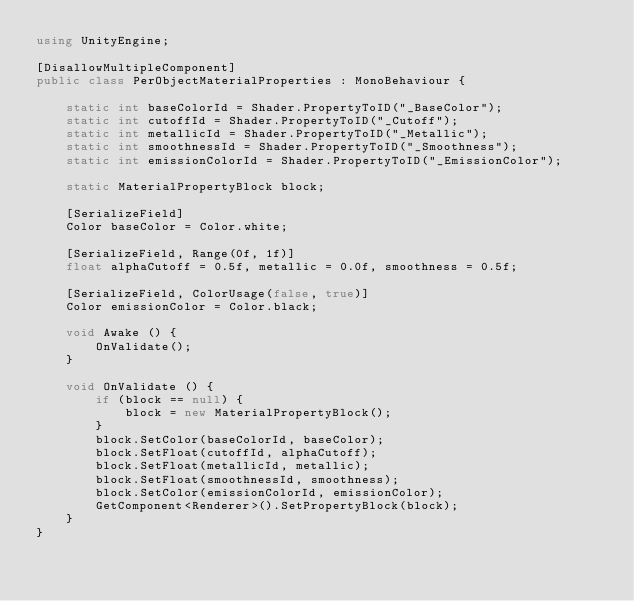<code> <loc_0><loc_0><loc_500><loc_500><_C#_>using UnityEngine;

[DisallowMultipleComponent]
public class PerObjectMaterialProperties : MonoBehaviour {

	static int baseColorId = Shader.PropertyToID("_BaseColor");
	static int cutoffId = Shader.PropertyToID("_Cutoff");
    static int metallicId = Shader.PropertyToID("_Metallic");
    static int smoothnessId = Shader.PropertyToID("_Smoothness");    
    static int emissionColorId = Shader.PropertyToID("_EmissionColor");

	static MaterialPropertyBlock block;

	[SerializeField]
	Color baseColor = Color.white;

	[SerializeField, Range(0f, 1f)]
	float alphaCutoff = 0.5f, metallic = 0.0f, smoothness = 0.5f;

    [SerializeField, ColorUsage(false, true)]
    Color emissionColor = Color.black;

    void Awake () {
		OnValidate();
	}

	void OnValidate () {
		if (block == null) {
			block = new MaterialPropertyBlock();
		}
		block.SetColor(baseColorId, baseColor);
		block.SetFloat(cutoffId, alphaCutoff);
        block.SetFloat(metallicId, metallic);
        block.SetFloat(smoothnessId, smoothness);
        block.SetColor(emissionColorId, emissionColor);
        GetComponent<Renderer>().SetPropertyBlock(block);
	}
}</code> 